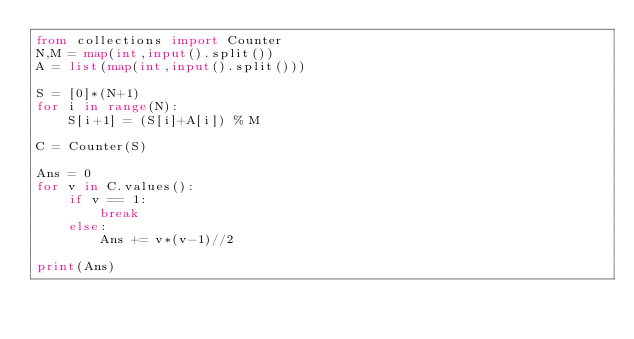Convert code to text. <code><loc_0><loc_0><loc_500><loc_500><_Python_>from collections import Counter
N,M = map(int,input().split())
A = list(map(int,input().split()))

S = [0]*(N+1)
for i in range(N):
    S[i+1] = (S[i]+A[i]) % M

C = Counter(S)

Ans = 0
for v in C.values():
    if v == 1:
        break
    else:
        Ans += v*(v-1)//2

print(Ans)</code> 